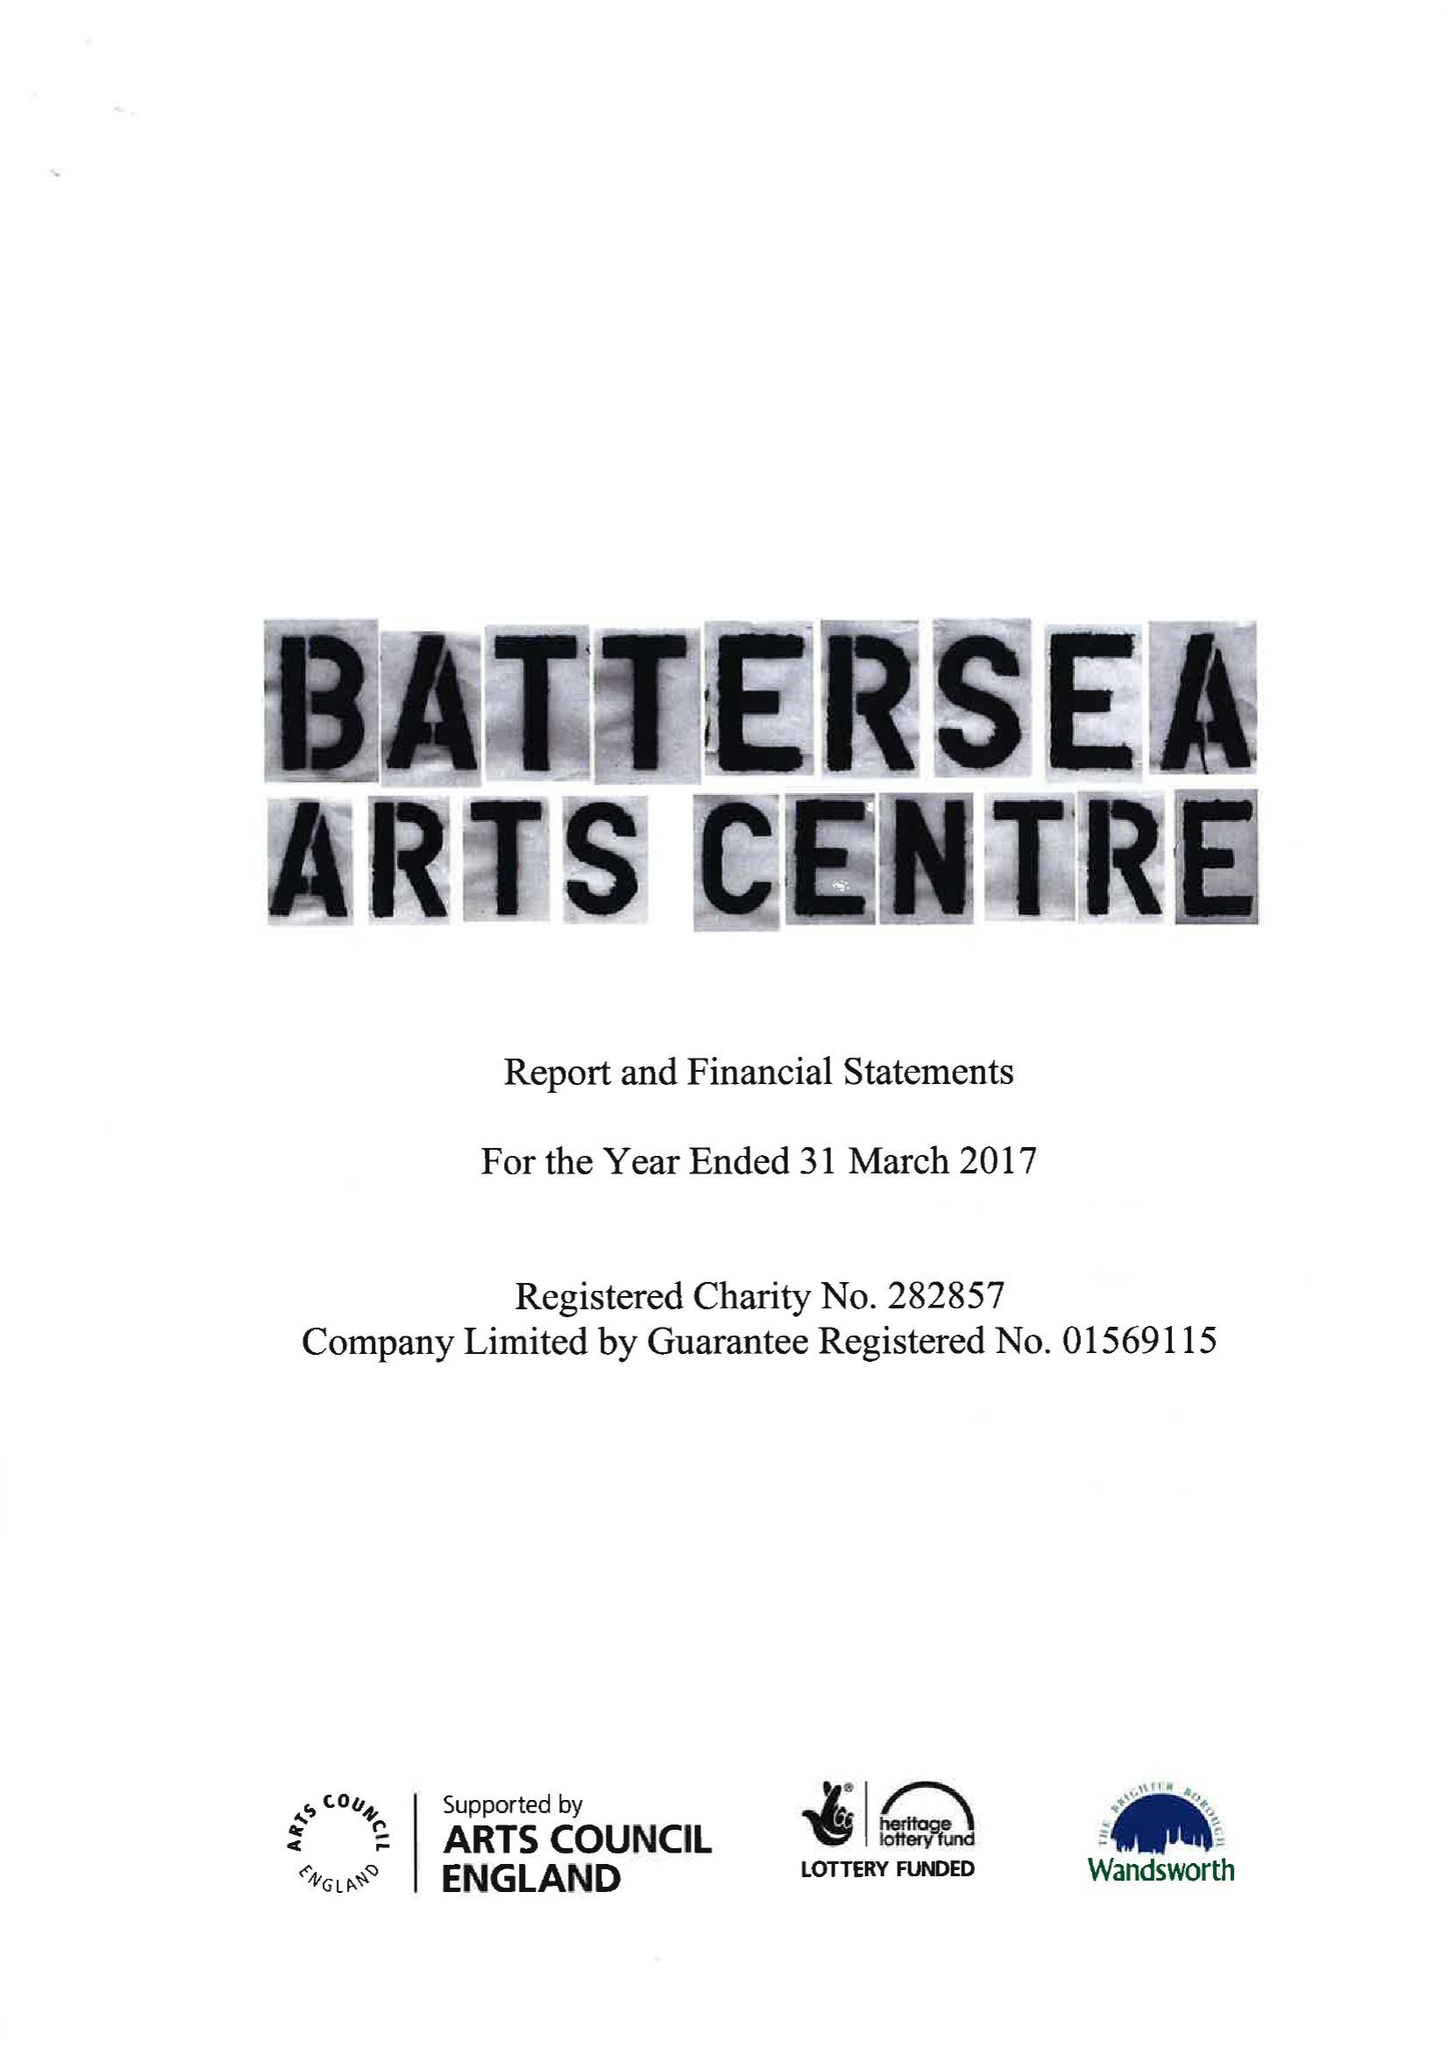What is the value for the spending_annually_in_british_pounds?
Answer the question using a single word or phrase. 5101343.00 